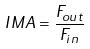<formula> <loc_0><loc_0><loc_500><loc_500>I M A = \frac { F _ { o u t } } { F _ { i n } }</formula> 